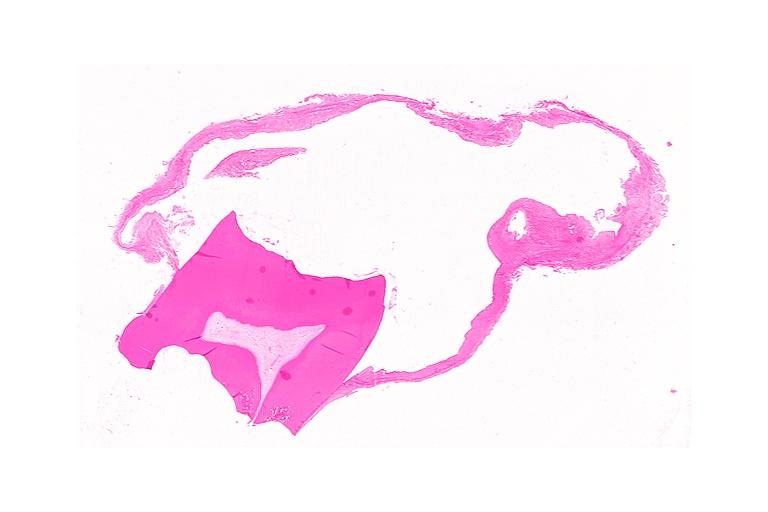s this good yellow color slide present?
Answer the question using a single word or phrase. No 